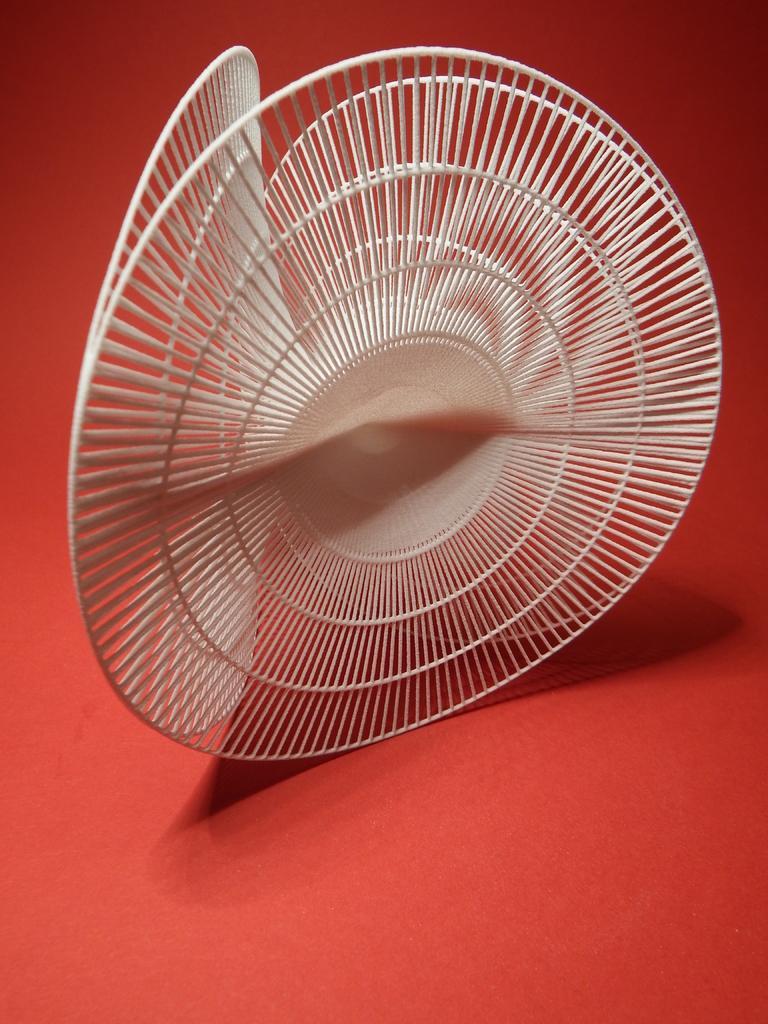Describe this image in one or two sentences. In this image there is an object. 